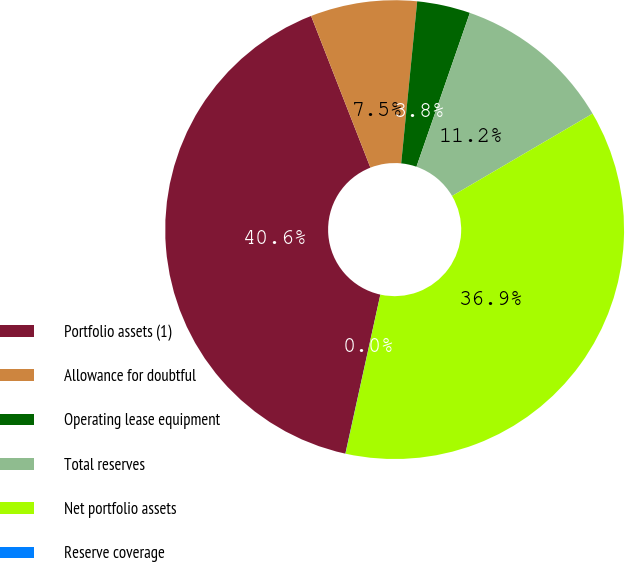Convert chart to OTSL. <chart><loc_0><loc_0><loc_500><loc_500><pie_chart><fcel>Portfolio assets (1)<fcel>Allowance for doubtful<fcel>Operating lease equipment<fcel>Total reserves<fcel>Net portfolio assets<fcel>Reserve coverage<nl><fcel>40.62%<fcel>7.5%<fcel>3.75%<fcel>11.25%<fcel>36.87%<fcel>0.01%<nl></chart> 